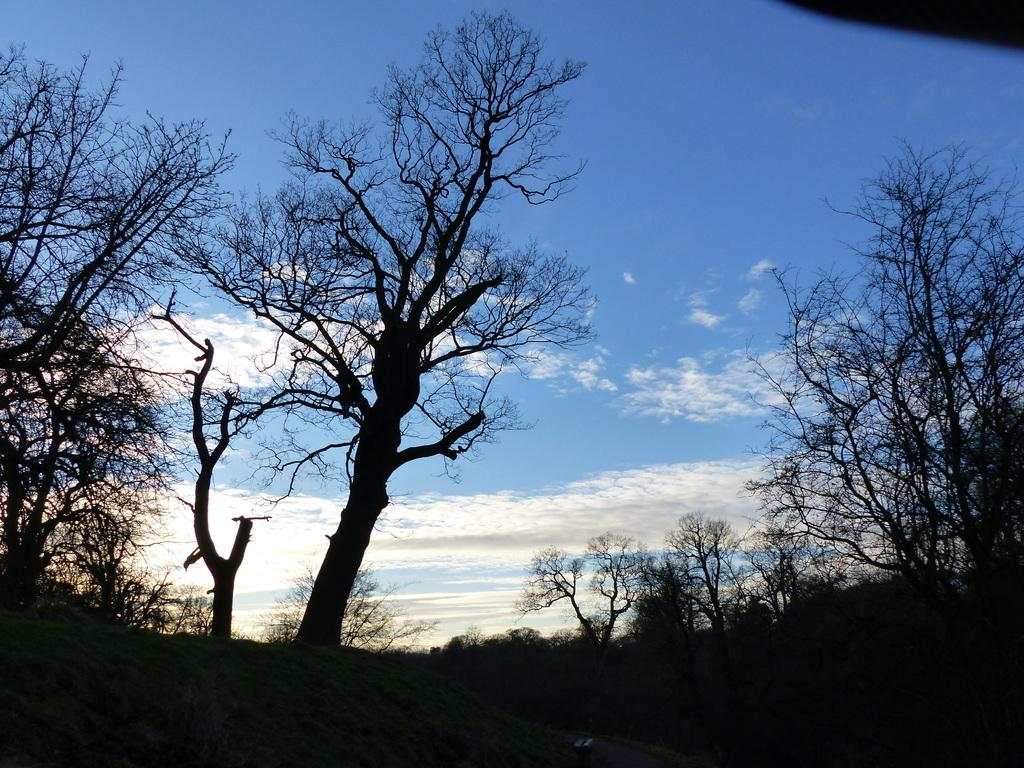What type of vegetation can be seen in the image? There are trees in the image. What is visible in the background of the image? The sky is visible in the image. What can be seen in the sky? Clouds are present in the sky. What type of pickle is hanging from the tree in the image? There is no pickle present in the image; it features trees and clouds in the sky. 